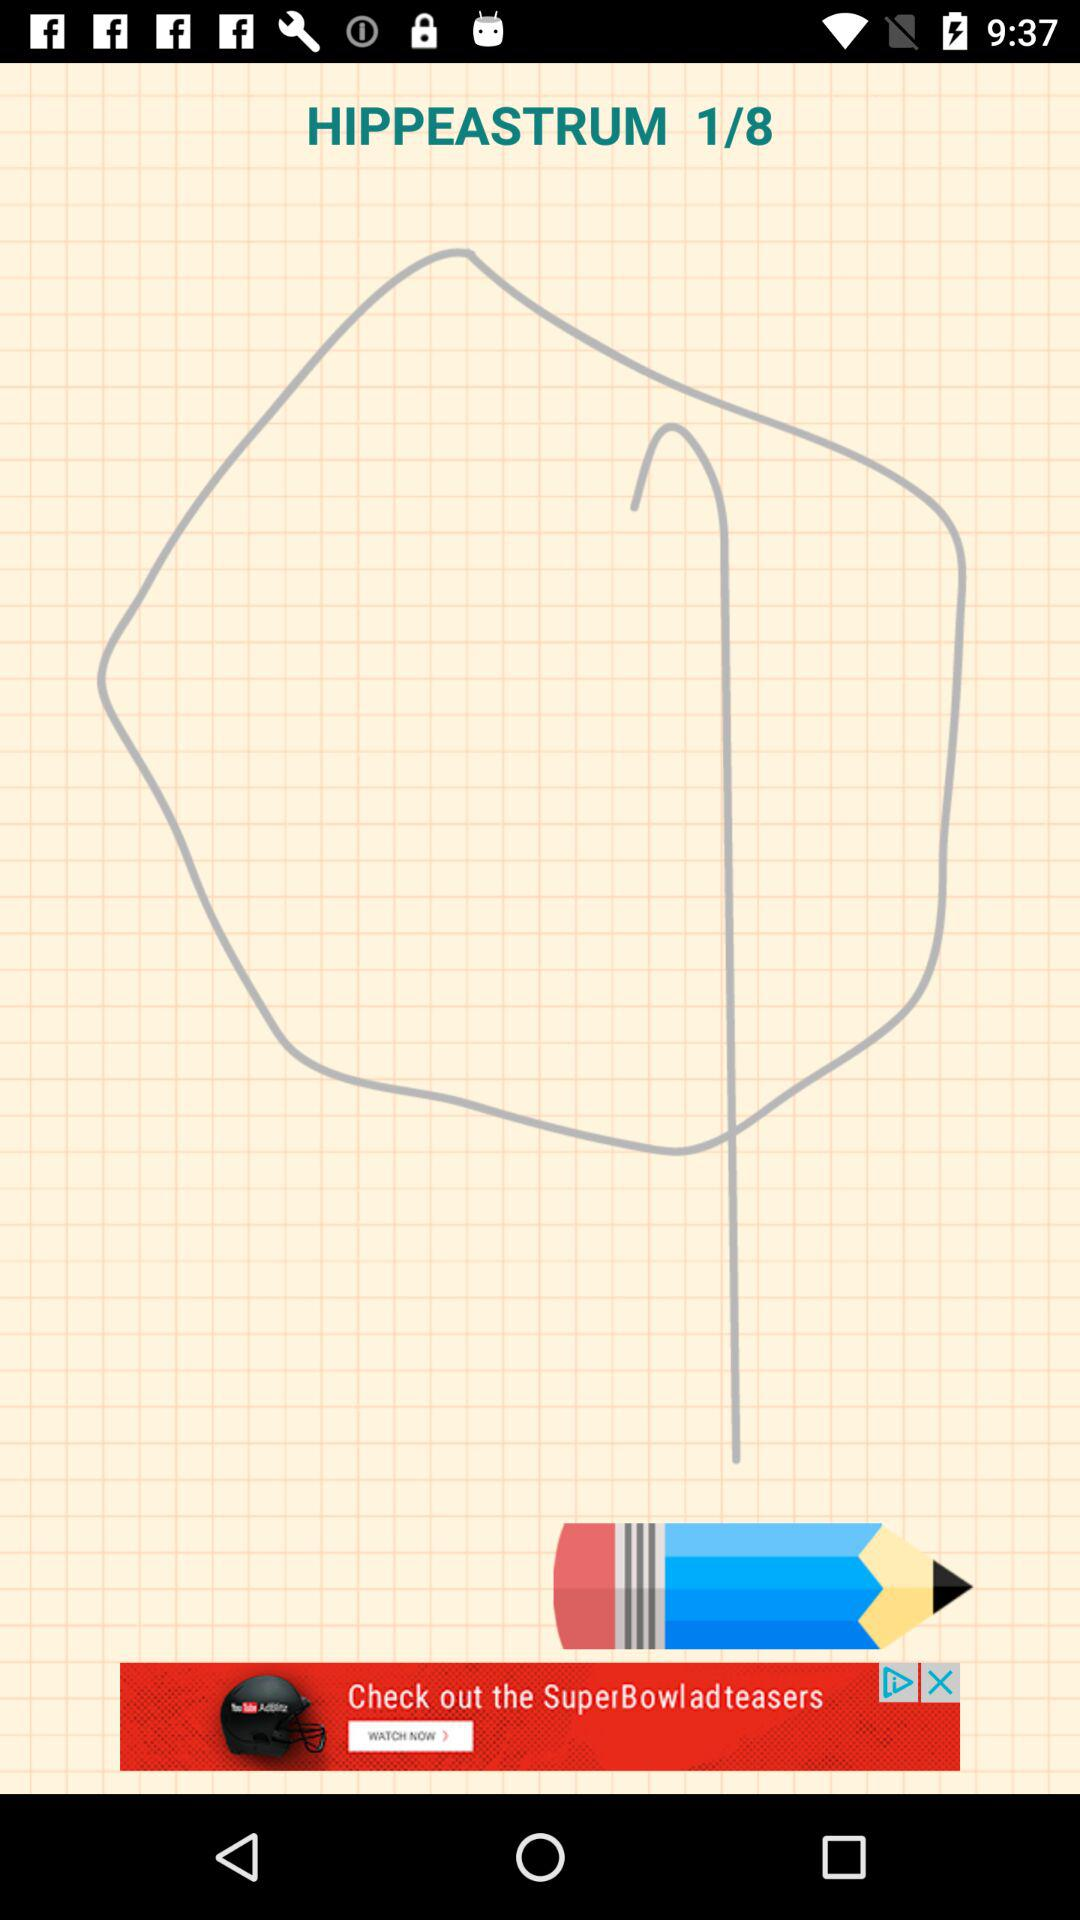What is the total number of images? The total number of images is 8. 